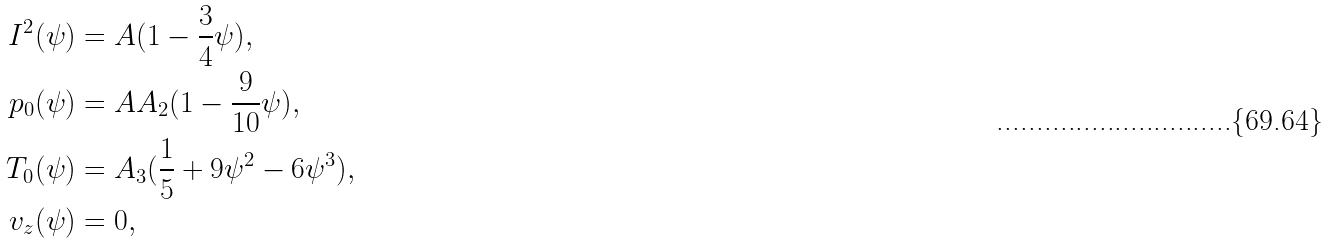<formula> <loc_0><loc_0><loc_500><loc_500>I ^ { 2 } ( \psi ) & = A ( 1 - \frac { 3 } { 4 } \psi ) , \\ p _ { 0 } ( \psi ) & = A A _ { 2 } ( 1 - \frac { 9 } { 1 0 } \psi ) , \\ T _ { 0 } ( \psi ) & = A _ { 3 } ( \frac { 1 } { 5 } + 9 \psi ^ { 2 } - 6 \psi ^ { 3 } ) , \\ v _ { z } ( \psi ) & = 0 ,</formula> 